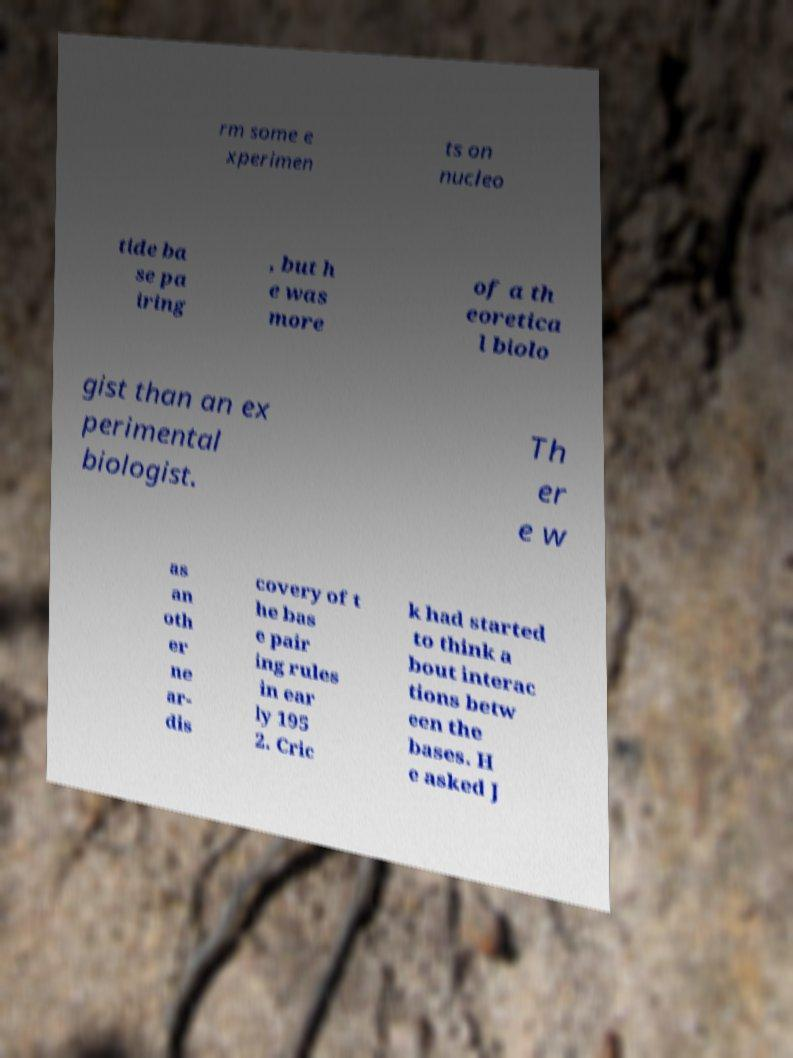Could you assist in decoding the text presented in this image and type it out clearly? rm some e xperimen ts on nucleo tide ba se pa iring , but h e was more of a th eoretica l biolo gist than an ex perimental biologist. Th er e w as an oth er ne ar- dis covery of t he bas e pair ing rules in ear ly 195 2. Cric k had started to think a bout interac tions betw een the bases. H e asked J 